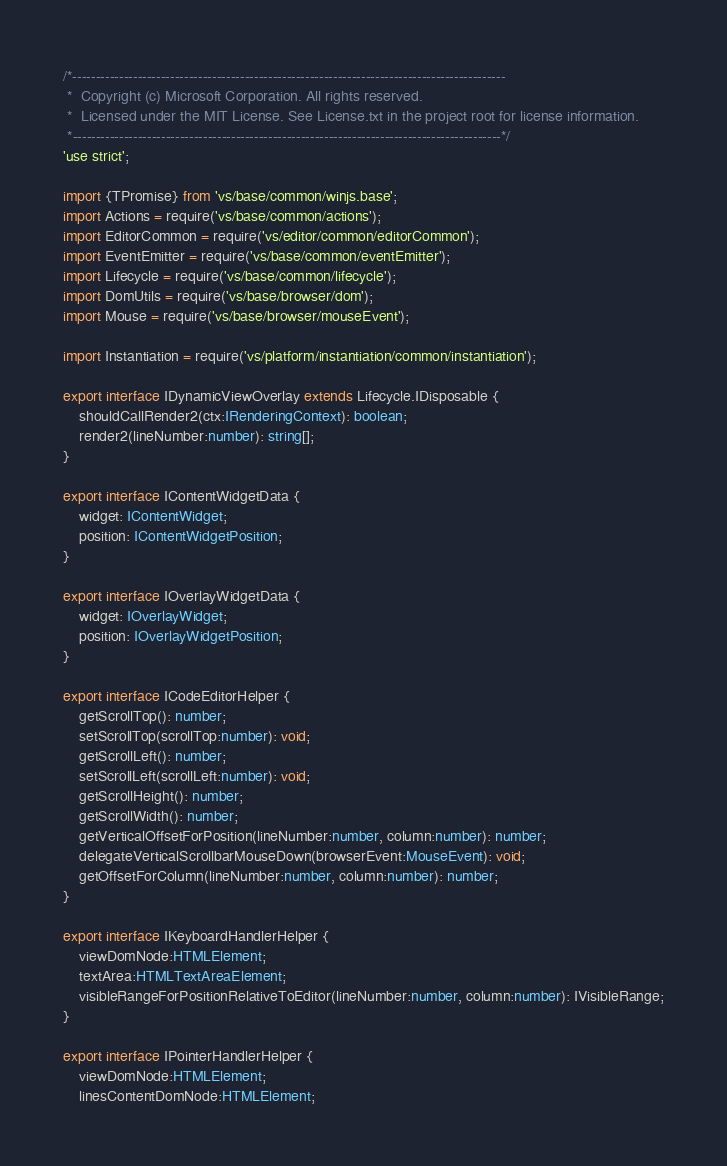<code> <loc_0><loc_0><loc_500><loc_500><_TypeScript_>/*---------------------------------------------------------------------------------------------
 *  Copyright (c) Microsoft Corporation. All rights reserved.
 *  Licensed under the MIT License. See License.txt in the project root for license information.
 *--------------------------------------------------------------------------------------------*/
'use strict';

import {TPromise} from 'vs/base/common/winjs.base';
import Actions = require('vs/base/common/actions');
import EditorCommon = require('vs/editor/common/editorCommon');
import EventEmitter = require('vs/base/common/eventEmitter');
import Lifecycle = require('vs/base/common/lifecycle');
import DomUtils = require('vs/base/browser/dom');
import Mouse = require('vs/base/browser/mouseEvent');

import Instantiation = require('vs/platform/instantiation/common/instantiation');

export interface IDynamicViewOverlay extends Lifecycle.IDisposable {
	shouldCallRender2(ctx:IRenderingContext): boolean;
	render2(lineNumber:number): string[];
}

export interface IContentWidgetData {
	widget: IContentWidget;
	position: IContentWidgetPosition;
}

export interface IOverlayWidgetData {
	widget: IOverlayWidget;
	position: IOverlayWidgetPosition;
}

export interface ICodeEditorHelper {
	getScrollTop(): number;
	setScrollTop(scrollTop:number): void;
	getScrollLeft(): number;
	setScrollLeft(scrollLeft:number): void;
	getScrollHeight(): number;
	getScrollWidth(): number;
	getVerticalOffsetForPosition(lineNumber:number, column:number): number;
	delegateVerticalScrollbarMouseDown(browserEvent:MouseEvent): void;
	getOffsetForColumn(lineNumber:number, column:number): number;
}

export interface IKeyboardHandlerHelper {
	viewDomNode:HTMLElement;
	textArea:HTMLTextAreaElement;
	visibleRangeForPositionRelativeToEditor(lineNumber:number, column:number): IVisibleRange;
}

export interface IPointerHandlerHelper {
	viewDomNode:HTMLElement;
	linesContentDomNode:HTMLElement;
</code> 